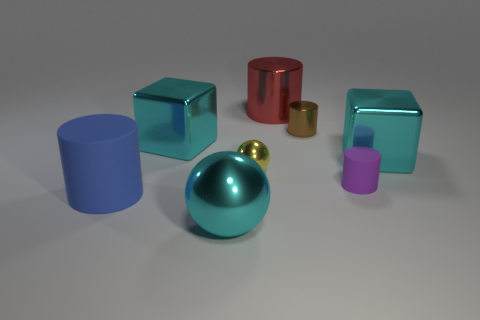Is there anything else that is the same material as the yellow thing?
Your response must be concise. Yes. The metallic cube on the left side of the yellow metal object is what color?
Your response must be concise. Cyan. Is the tiny brown thing made of the same material as the large cylinder behind the brown shiny thing?
Give a very brief answer. Yes. What material is the small purple thing?
Make the answer very short. Rubber. There is a yellow object that is the same material as the red thing; what is its shape?
Ensure brevity in your answer.  Sphere. How many other objects are the same shape as the blue thing?
Offer a terse response. 3. How many big red objects are on the right side of the brown cylinder?
Offer a terse response. 0. Is the size of the cyan metallic block that is to the right of the small metal sphere the same as the cyan metallic cube that is on the left side of the purple matte cylinder?
Make the answer very short. Yes. What number of other objects are the same size as the purple rubber cylinder?
Provide a short and direct response. 2. The tiny thing that is behind the large block that is on the right side of the cyan shiny block to the left of the red thing is made of what material?
Provide a short and direct response. Metal. 